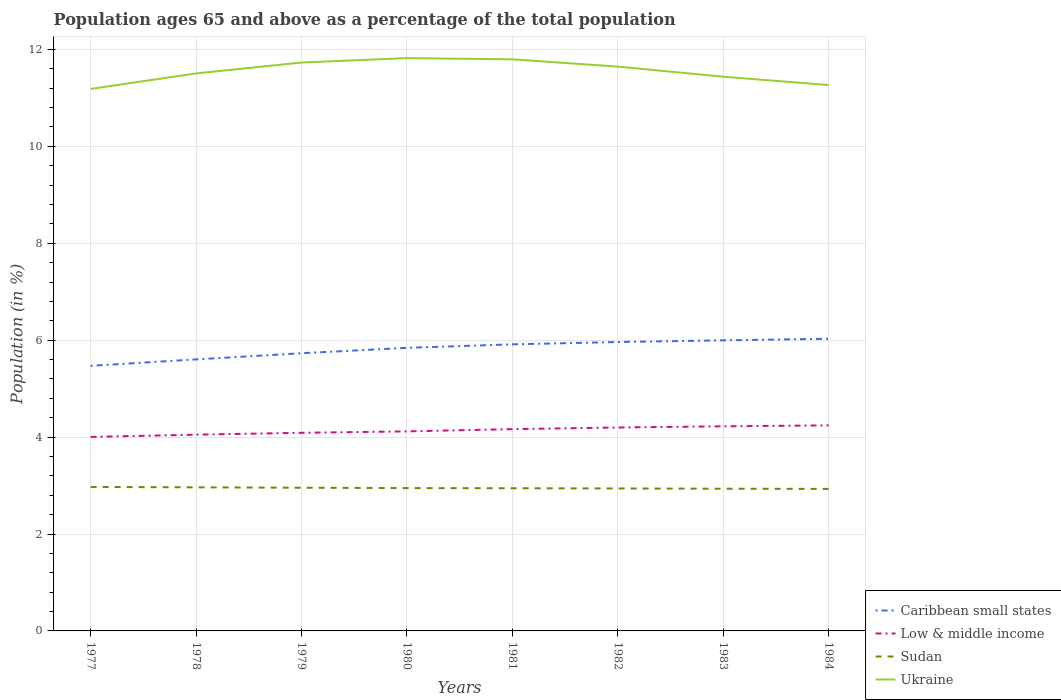How many different coloured lines are there?
Your answer should be very brief. 4. Does the line corresponding to Caribbean small states intersect with the line corresponding to Ukraine?
Give a very brief answer. No. Across all years, what is the maximum percentage of the population ages 65 and above in Ukraine?
Your answer should be compact. 11.18. What is the total percentage of the population ages 65 and above in Sudan in the graph?
Keep it short and to the point. 0.01. What is the difference between the highest and the second highest percentage of the population ages 65 and above in Ukraine?
Keep it short and to the point. 0.64. What is the difference between the highest and the lowest percentage of the population ages 65 and above in Caribbean small states?
Keep it short and to the point. 5. Is the percentage of the population ages 65 and above in Low & middle income strictly greater than the percentage of the population ages 65 and above in Sudan over the years?
Offer a terse response. No. What is the difference between two consecutive major ticks on the Y-axis?
Your response must be concise. 2. Does the graph contain any zero values?
Offer a very short reply. No. How are the legend labels stacked?
Ensure brevity in your answer.  Vertical. What is the title of the graph?
Provide a short and direct response. Population ages 65 and above as a percentage of the total population. What is the label or title of the Y-axis?
Your response must be concise. Population (in %). What is the Population (in %) of Caribbean small states in 1977?
Give a very brief answer. 5.47. What is the Population (in %) of Low & middle income in 1977?
Your response must be concise. 4. What is the Population (in %) in Sudan in 1977?
Your response must be concise. 2.97. What is the Population (in %) of Ukraine in 1977?
Give a very brief answer. 11.18. What is the Population (in %) in Caribbean small states in 1978?
Make the answer very short. 5.6. What is the Population (in %) in Low & middle income in 1978?
Offer a terse response. 4.05. What is the Population (in %) in Sudan in 1978?
Give a very brief answer. 2.96. What is the Population (in %) of Ukraine in 1978?
Your response must be concise. 11.5. What is the Population (in %) of Caribbean small states in 1979?
Your answer should be compact. 5.73. What is the Population (in %) of Low & middle income in 1979?
Provide a succinct answer. 4.09. What is the Population (in %) of Sudan in 1979?
Make the answer very short. 2.95. What is the Population (in %) of Ukraine in 1979?
Provide a short and direct response. 11.73. What is the Population (in %) of Caribbean small states in 1980?
Offer a terse response. 5.84. What is the Population (in %) in Low & middle income in 1980?
Your answer should be very brief. 4.12. What is the Population (in %) in Sudan in 1980?
Ensure brevity in your answer.  2.95. What is the Population (in %) in Ukraine in 1980?
Your answer should be compact. 11.82. What is the Population (in %) of Caribbean small states in 1981?
Give a very brief answer. 5.91. What is the Population (in %) in Low & middle income in 1981?
Ensure brevity in your answer.  4.16. What is the Population (in %) of Sudan in 1981?
Your answer should be very brief. 2.94. What is the Population (in %) in Ukraine in 1981?
Offer a terse response. 11.8. What is the Population (in %) of Caribbean small states in 1982?
Make the answer very short. 5.96. What is the Population (in %) of Low & middle income in 1982?
Offer a very short reply. 4.2. What is the Population (in %) of Sudan in 1982?
Provide a succinct answer. 2.94. What is the Population (in %) of Ukraine in 1982?
Your answer should be compact. 11.65. What is the Population (in %) of Caribbean small states in 1983?
Offer a terse response. 6. What is the Population (in %) in Low & middle income in 1983?
Provide a short and direct response. 4.22. What is the Population (in %) of Sudan in 1983?
Your answer should be very brief. 2.93. What is the Population (in %) of Ukraine in 1983?
Your answer should be very brief. 11.44. What is the Population (in %) in Caribbean small states in 1984?
Your answer should be very brief. 6.03. What is the Population (in %) in Low & middle income in 1984?
Offer a terse response. 4.24. What is the Population (in %) of Sudan in 1984?
Provide a succinct answer. 2.93. What is the Population (in %) of Ukraine in 1984?
Provide a succinct answer. 11.26. Across all years, what is the maximum Population (in %) of Caribbean small states?
Offer a very short reply. 6.03. Across all years, what is the maximum Population (in %) in Low & middle income?
Offer a terse response. 4.24. Across all years, what is the maximum Population (in %) in Sudan?
Keep it short and to the point. 2.97. Across all years, what is the maximum Population (in %) of Ukraine?
Provide a succinct answer. 11.82. Across all years, what is the minimum Population (in %) of Caribbean small states?
Offer a very short reply. 5.47. Across all years, what is the minimum Population (in %) in Low & middle income?
Make the answer very short. 4. Across all years, what is the minimum Population (in %) of Sudan?
Offer a terse response. 2.93. Across all years, what is the minimum Population (in %) of Ukraine?
Provide a short and direct response. 11.18. What is the total Population (in %) in Caribbean small states in the graph?
Provide a succinct answer. 46.55. What is the total Population (in %) in Low & middle income in the graph?
Offer a terse response. 33.09. What is the total Population (in %) of Sudan in the graph?
Offer a very short reply. 23.59. What is the total Population (in %) of Ukraine in the graph?
Make the answer very short. 92.38. What is the difference between the Population (in %) of Caribbean small states in 1977 and that in 1978?
Provide a succinct answer. -0.13. What is the difference between the Population (in %) in Low & middle income in 1977 and that in 1978?
Make the answer very short. -0.05. What is the difference between the Population (in %) of Sudan in 1977 and that in 1978?
Ensure brevity in your answer.  0.01. What is the difference between the Population (in %) of Ukraine in 1977 and that in 1978?
Keep it short and to the point. -0.32. What is the difference between the Population (in %) of Caribbean small states in 1977 and that in 1979?
Give a very brief answer. -0.26. What is the difference between the Population (in %) of Low & middle income in 1977 and that in 1979?
Give a very brief answer. -0.09. What is the difference between the Population (in %) of Sudan in 1977 and that in 1979?
Ensure brevity in your answer.  0.02. What is the difference between the Population (in %) in Ukraine in 1977 and that in 1979?
Keep it short and to the point. -0.54. What is the difference between the Population (in %) of Caribbean small states in 1977 and that in 1980?
Ensure brevity in your answer.  -0.37. What is the difference between the Population (in %) of Low & middle income in 1977 and that in 1980?
Your response must be concise. -0.11. What is the difference between the Population (in %) in Sudan in 1977 and that in 1980?
Offer a very short reply. 0.02. What is the difference between the Population (in %) in Ukraine in 1977 and that in 1980?
Ensure brevity in your answer.  -0.64. What is the difference between the Population (in %) in Caribbean small states in 1977 and that in 1981?
Your response must be concise. -0.44. What is the difference between the Population (in %) of Low & middle income in 1977 and that in 1981?
Offer a very short reply. -0.16. What is the difference between the Population (in %) of Sudan in 1977 and that in 1981?
Ensure brevity in your answer.  0.03. What is the difference between the Population (in %) of Ukraine in 1977 and that in 1981?
Provide a short and direct response. -0.61. What is the difference between the Population (in %) in Caribbean small states in 1977 and that in 1982?
Ensure brevity in your answer.  -0.49. What is the difference between the Population (in %) in Low & middle income in 1977 and that in 1982?
Provide a short and direct response. -0.19. What is the difference between the Population (in %) of Sudan in 1977 and that in 1982?
Your answer should be very brief. 0.03. What is the difference between the Population (in %) in Ukraine in 1977 and that in 1982?
Provide a short and direct response. -0.46. What is the difference between the Population (in %) in Caribbean small states in 1977 and that in 1983?
Make the answer very short. -0.53. What is the difference between the Population (in %) in Low & middle income in 1977 and that in 1983?
Your response must be concise. -0.22. What is the difference between the Population (in %) of Sudan in 1977 and that in 1983?
Keep it short and to the point. 0.04. What is the difference between the Population (in %) in Ukraine in 1977 and that in 1983?
Offer a very short reply. -0.25. What is the difference between the Population (in %) of Caribbean small states in 1977 and that in 1984?
Your answer should be very brief. -0.56. What is the difference between the Population (in %) in Low & middle income in 1977 and that in 1984?
Your answer should be very brief. -0.24. What is the difference between the Population (in %) of Sudan in 1977 and that in 1984?
Provide a short and direct response. 0.04. What is the difference between the Population (in %) in Ukraine in 1977 and that in 1984?
Provide a succinct answer. -0.08. What is the difference between the Population (in %) of Caribbean small states in 1978 and that in 1979?
Your answer should be compact. -0.13. What is the difference between the Population (in %) of Low & middle income in 1978 and that in 1979?
Your answer should be very brief. -0.04. What is the difference between the Population (in %) in Sudan in 1978 and that in 1979?
Keep it short and to the point. 0.01. What is the difference between the Population (in %) of Ukraine in 1978 and that in 1979?
Your answer should be very brief. -0.22. What is the difference between the Population (in %) in Caribbean small states in 1978 and that in 1980?
Make the answer very short. -0.24. What is the difference between the Population (in %) of Low & middle income in 1978 and that in 1980?
Your response must be concise. -0.07. What is the difference between the Population (in %) of Sudan in 1978 and that in 1980?
Keep it short and to the point. 0.02. What is the difference between the Population (in %) of Ukraine in 1978 and that in 1980?
Your answer should be very brief. -0.32. What is the difference between the Population (in %) of Caribbean small states in 1978 and that in 1981?
Offer a terse response. -0.31. What is the difference between the Population (in %) of Low & middle income in 1978 and that in 1981?
Provide a succinct answer. -0.11. What is the difference between the Population (in %) of Sudan in 1978 and that in 1981?
Provide a succinct answer. 0.02. What is the difference between the Population (in %) of Ukraine in 1978 and that in 1981?
Make the answer very short. -0.29. What is the difference between the Population (in %) of Caribbean small states in 1978 and that in 1982?
Your answer should be compact. -0.36. What is the difference between the Population (in %) in Low & middle income in 1978 and that in 1982?
Your answer should be very brief. -0.15. What is the difference between the Population (in %) in Sudan in 1978 and that in 1982?
Keep it short and to the point. 0.02. What is the difference between the Population (in %) of Ukraine in 1978 and that in 1982?
Offer a terse response. -0.14. What is the difference between the Population (in %) of Caribbean small states in 1978 and that in 1983?
Your response must be concise. -0.39. What is the difference between the Population (in %) in Low & middle income in 1978 and that in 1983?
Offer a terse response. -0.17. What is the difference between the Population (in %) of Sudan in 1978 and that in 1983?
Your response must be concise. 0.03. What is the difference between the Population (in %) of Ukraine in 1978 and that in 1983?
Your answer should be very brief. 0.07. What is the difference between the Population (in %) in Caribbean small states in 1978 and that in 1984?
Make the answer very short. -0.43. What is the difference between the Population (in %) in Low & middle income in 1978 and that in 1984?
Your answer should be very brief. -0.19. What is the difference between the Population (in %) of Sudan in 1978 and that in 1984?
Make the answer very short. 0.03. What is the difference between the Population (in %) of Ukraine in 1978 and that in 1984?
Make the answer very short. 0.24. What is the difference between the Population (in %) in Caribbean small states in 1979 and that in 1980?
Offer a terse response. -0.11. What is the difference between the Population (in %) in Low & middle income in 1979 and that in 1980?
Give a very brief answer. -0.03. What is the difference between the Population (in %) in Sudan in 1979 and that in 1980?
Offer a very short reply. 0.01. What is the difference between the Population (in %) of Ukraine in 1979 and that in 1980?
Keep it short and to the point. -0.09. What is the difference between the Population (in %) of Caribbean small states in 1979 and that in 1981?
Offer a terse response. -0.18. What is the difference between the Population (in %) in Low & middle income in 1979 and that in 1981?
Give a very brief answer. -0.08. What is the difference between the Population (in %) in Sudan in 1979 and that in 1981?
Your answer should be very brief. 0.01. What is the difference between the Population (in %) in Ukraine in 1979 and that in 1981?
Offer a very short reply. -0.07. What is the difference between the Population (in %) of Caribbean small states in 1979 and that in 1982?
Ensure brevity in your answer.  -0.23. What is the difference between the Population (in %) in Low & middle income in 1979 and that in 1982?
Your answer should be compact. -0.11. What is the difference between the Population (in %) in Sudan in 1979 and that in 1982?
Provide a succinct answer. 0.02. What is the difference between the Population (in %) of Ukraine in 1979 and that in 1982?
Offer a terse response. 0.08. What is the difference between the Population (in %) in Caribbean small states in 1979 and that in 1983?
Make the answer very short. -0.27. What is the difference between the Population (in %) in Low & middle income in 1979 and that in 1983?
Your answer should be very brief. -0.13. What is the difference between the Population (in %) of Sudan in 1979 and that in 1983?
Ensure brevity in your answer.  0.02. What is the difference between the Population (in %) in Ukraine in 1979 and that in 1983?
Your response must be concise. 0.29. What is the difference between the Population (in %) of Caribbean small states in 1979 and that in 1984?
Your answer should be compact. -0.3. What is the difference between the Population (in %) of Low & middle income in 1979 and that in 1984?
Provide a short and direct response. -0.15. What is the difference between the Population (in %) in Sudan in 1979 and that in 1984?
Ensure brevity in your answer.  0.02. What is the difference between the Population (in %) in Ukraine in 1979 and that in 1984?
Provide a short and direct response. 0.47. What is the difference between the Population (in %) of Caribbean small states in 1980 and that in 1981?
Give a very brief answer. -0.07. What is the difference between the Population (in %) of Low & middle income in 1980 and that in 1981?
Offer a very short reply. -0.05. What is the difference between the Population (in %) of Sudan in 1980 and that in 1981?
Offer a terse response. 0. What is the difference between the Population (in %) in Ukraine in 1980 and that in 1981?
Provide a short and direct response. 0.03. What is the difference between the Population (in %) of Caribbean small states in 1980 and that in 1982?
Ensure brevity in your answer.  -0.12. What is the difference between the Population (in %) in Low & middle income in 1980 and that in 1982?
Ensure brevity in your answer.  -0.08. What is the difference between the Population (in %) of Sudan in 1980 and that in 1982?
Provide a short and direct response. 0.01. What is the difference between the Population (in %) of Ukraine in 1980 and that in 1982?
Make the answer very short. 0.18. What is the difference between the Population (in %) of Caribbean small states in 1980 and that in 1983?
Your answer should be compact. -0.15. What is the difference between the Population (in %) of Low & middle income in 1980 and that in 1983?
Ensure brevity in your answer.  -0.1. What is the difference between the Population (in %) of Sudan in 1980 and that in 1983?
Offer a very short reply. 0.01. What is the difference between the Population (in %) in Ukraine in 1980 and that in 1983?
Offer a very short reply. 0.38. What is the difference between the Population (in %) of Caribbean small states in 1980 and that in 1984?
Keep it short and to the point. -0.19. What is the difference between the Population (in %) in Low & middle income in 1980 and that in 1984?
Keep it short and to the point. -0.12. What is the difference between the Population (in %) of Sudan in 1980 and that in 1984?
Your answer should be compact. 0.02. What is the difference between the Population (in %) in Ukraine in 1980 and that in 1984?
Your answer should be very brief. 0.56. What is the difference between the Population (in %) of Caribbean small states in 1981 and that in 1982?
Keep it short and to the point. -0.05. What is the difference between the Population (in %) in Low & middle income in 1981 and that in 1982?
Your answer should be very brief. -0.03. What is the difference between the Population (in %) of Sudan in 1981 and that in 1982?
Make the answer very short. 0. What is the difference between the Population (in %) in Ukraine in 1981 and that in 1982?
Provide a short and direct response. 0.15. What is the difference between the Population (in %) of Caribbean small states in 1981 and that in 1983?
Ensure brevity in your answer.  -0.08. What is the difference between the Population (in %) in Low & middle income in 1981 and that in 1983?
Offer a terse response. -0.06. What is the difference between the Population (in %) of Sudan in 1981 and that in 1983?
Ensure brevity in your answer.  0.01. What is the difference between the Population (in %) in Ukraine in 1981 and that in 1983?
Make the answer very short. 0.36. What is the difference between the Population (in %) of Caribbean small states in 1981 and that in 1984?
Make the answer very short. -0.12. What is the difference between the Population (in %) in Low & middle income in 1981 and that in 1984?
Your response must be concise. -0.08. What is the difference between the Population (in %) in Sudan in 1981 and that in 1984?
Provide a succinct answer. 0.01. What is the difference between the Population (in %) in Ukraine in 1981 and that in 1984?
Keep it short and to the point. 0.53. What is the difference between the Population (in %) of Caribbean small states in 1982 and that in 1983?
Your answer should be compact. -0.03. What is the difference between the Population (in %) of Low & middle income in 1982 and that in 1983?
Offer a very short reply. -0.02. What is the difference between the Population (in %) of Sudan in 1982 and that in 1983?
Provide a succinct answer. 0.01. What is the difference between the Population (in %) in Ukraine in 1982 and that in 1983?
Make the answer very short. 0.21. What is the difference between the Population (in %) of Caribbean small states in 1982 and that in 1984?
Give a very brief answer. -0.07. What is the difference between the Population (in %) in Low & middle income in 1982 and that in 1984?
Keep it short and to the point. -0.04. What is the difference between the Population (in %) of Sudan in 1982 and that in 1984?
Make the answer very short. 0.01. What is the difference between the Population (in %) in Ukraine in 1982 and that in 1984?
Give a very brief answer. 0.38. What is the difference between the Population (in %) of Caribbean small states in 1983 and that in 1984?
Offer a terse response. -0.03. What is the difference between the Population (in %) of Low & middle income in 1983 and that in 1984?
Provide a short and direct response. -0.02. What is the difference between the Population (in %) of Sudan in 1983 and that in 1984?
Your response must be concise. 0. What is the difference between the Population (in %) in Ukraine in 1983 and that in 1984?
Make the answer very short. 0.17. What is the difference between the Population (in %) of Caribbean small states in 1977 and the Population (in %) of Low & middle income in 1978?
Give a very brief answer. 1.42. What is the difference between the Population (in %) of Caribbean small states in 1977 and the Population (in %) of Sudan in 1978?
Your answer should be compact. 2.51. What is the difference between the Population (in %) of Caribbean small states in 1977 and the Population (in %) of Ukraine in 1978?
Give a very brief answer. -6.03. What is the difference between the Population (in %) in Low & middle income in 1977 and the Population (in %) in Ukraine in 1978?
Make the answer very short. -7.5. What is the difference between the Population (in %) in Sudan in 1977 and the Population (in %) in Ukraine in 1978?
Provide a short and direct response. -8.53. What is the difference between the Population (in %) in Caribbean small states in 1977 and the Population (in %) in Low & middle income in 1979?
Keep it short and to the point. 1.38. What is the difference between the Population (in %) in Caribbean small states in 1977 and the Population (in %) in Sudan in 1979?
Make the answer very short. 2.52. What is the difference between the Population (in %) of Caribbean small states in 1977 and the Population (in %) of Ukraine in 1979?
Your response must be concise. -6.26. What is the difference between the Population (in %) in Low & middle income in 1977 and the Population (in %) in Sudan in 1979?
Your answer should be compact. 1.05. What is the difference between the Population (in %) in Low & middle income in 1977 and the Population (in %) in Ukraine in 1979?
Offer a very short reply. -7.73. What is the difference between the Population (in %) of Sudan in 1977 and the Population (in %) of Ukraine in 1979?
Offer a terse response. -8.76. What is the difference between the Population (in %) in Caribbean small states in 1977 and the Population (in %) in Low & middle income in 1980?
Your answer should be very brief. 1.35. What is the difference between the Population (in %) of Caribbean small states in 1977 and the Population (in %) of Sudan in 1980?
Your response must be concise. 2.52. What is the difference between the Population (in %) in Caribbean small states in 1977 and the Population (in %) in Ukraine in 1980?
Provide a succinct answer. -6.35. What is the difference between the Population (in %) in Low & middle income in 1977 and the Population (in %) in Sudan in 1980?
Make the answer very short. 1.06. What is the difference between the Population (in %) of Low & middle income in 1977 and the Population (in %) of Ukraine in 1980?
Your answer should be very brief. -7.82. What is the difference between the Population (in %) in Sudan in 1977 and the Population (in %) in Ukraine in 1980?
Your answer should be very brief. -8.85. What is the difference between the Population (in %) in Caribbean small states in 1977 and the Population (in %) in Low & middle income in 1981?
Offer a terse response. 1.31. What is the difference between the Population (in %) of Caribbean small states in 1977 and the Population (in %) of Sudan in 1981?
Keep it short and to the point. 2.53. What is the difference between the Population (in %) of Caribbean small states in 1977 and the Population (in %) of Ukraine in 1981?
Make the answer very short. -6.32. What is the difference between the Population (in %) of Low & middle income in 1977 and the Population (in %) of Sudan in 1981?
Provide a succinct answer. 1.06. What is the difference between the Population (in %) of Low & middle income in 1977 and the Population (in %) of Ukraine in 1981?
Provide a succinct answer. -7.79. What is the difference between the Population (in %) in Sudan in 1977 and the Population (in %) in Ukraine in 1981?
Your answer should be very brief. -8.82. What is the difference between the Population (in %) of Caribbean small states in 1977 and the Population (in %) of Low & middle income in 1982?
Offer a very short reply. 1.27. What is the difference between the Population (in %) of Caribbean small states in 1977 and the Population (in %) of Sudan in 1982?
Provide a succinct answer. 2.53. What is the difference between the Population (in %) in Caribbean small states in 1977 and the Population (in %) in Ukraine in 1982?
Your response must be concise. -6.17. What is the difference between the Population (in %) in Low & middle income in 1977 and the Population (in %) in Sudan in 1982?
Offer a very short reply. 1.06. What is the difference between the Population (in %) of Low & middle income in 1977 and the Population (in %) of Ukraine in 1982?
Your answer should be very brief. -7.64. What is the difference between the Population (in %) in Sudan in 1977 and the Population (in %) in Ukraine in 1982?
Provide a short and direct response. -8.67. What is the difference between the Population (in %) of Caribbean small states in 1977 and the Population (in %) of Low & middle income in 1983?
Offer a terse response. 1.25. What is the difference between the Population (in %) in Caribbean small states in 1977 and the Population (in %) in Sudan in 1983?
Make the answer very short. 2.54. What is the difference between the Population (in %) in Caribbean small states in 1977 and the Population (in %) in Ukraine in 1983?
Provide a short and direct response. -5.97. What is the difference between the Population (in %) in Low & middle income in 1977 and the Population (in %) in Sudan in 1983?
Give a very brief answer. 1.07. What is the difference between the Population (in %) of Low & middle income in 1977 and the Population (in %) of Ukraine in 1983?
Ensure brevity in your answer.  -7.43. What is the difference between the Population (in %) in Sudan in 1977 and the Population (in %) in Ukraine in 1983?
Give a very brief answer. -8.47. What is the difference between the Population (in %) in Caribbean small states in 1977 and the Population (in %) in Low & middle income in 1984?
Keep it short and to the point. 1.23. What is the difference between the Population (in %) in Caribbean small states in 1977 and the Population (in %) in Sudan in 1984?
Offer a very short reply. 2.54. What is the difference between the Population (in %) of Caribbean small states in 1977 and the Population (in %) of Ukraine in 1984?
Provide a short and direct response. -5.79. What is the difference between the Population (in %) in Low & middle income in 1977 and the Population (in %) in Sudan in 1984?
Provide a succinct answer. 1.07. What is the difference between the Population (in %) of Low & middle income in 1977 and the Population (in %) of Ukraine in 1984?
Your response must be concise. -7.26. What is the difference between the Population (in %) of Sudan in 1977 and the Population (in %) of Ukraine in 1984?
Offer a very short reply. -8.29. What is the difference between the Population (in %) of Caribbean small states in 1978 and the Population (in %) of Low & middle income in 1979?
Provide a short and direct response. 1.51. What is the difference between the Population (in %) in Caribbean small states in 1978 and the Population (in %) in Sudan in 1979?
Provide a succinct answer. 2.65. What is the difference between the Population (in %) of Caribbean small states in 1978 and the Population (in %) of Ukraine in 1979?
Ensure brevity in your answer.  -6.13. What is the difference between the Population (in %) in Low & middle income in 1978 and the Population (in %) in Sudan in 1979?
Ensure brevity in your answer.  1.09. What is the difference between the Population (in %) in Low & middle income in 1978 and the Population (in %) in Ukraine in 1979?
Give a very brief answer. -7.68. What is the difference between the Population (in %) in Sudan in 1978 and the Population (in %) in Ukraine in 1979?
Your answer should be compact. -8.77. What is the difference between the Population (in %) of Caribbean small states in 1978 and the Population (in %) of Low & middle income in 1980?
Your answer should be compact. 1.49. What is the difference between the Population (in %) of Caribbean small states in 1978 and the Population (in %) of Sudan in 1980?
Offer a very short reply. 2.66. What is the difference between the Population (in %) of Caribbean small states in 1978 and the Population (in %) of Ukraine in 1980?
Your response must be concise. -6.22. What is the difference between the Population (in %) in Low & middle income in 1978 and the Population (in %) in Sudan in 1980?
Ensure brevity in your answer.  1.1. What is the difference between the Population (in %) of Low & middle income in 1978 and the Population (in %) of Ukraine in 1980?
Provide a short and direct response. -7.77. What is the difference between the Population (in %) of Sudan in 1978 and the Population (in %) of Ukraine in 1980?
Offer a terse response. -8.86. What is the difference between the Population (in %) of Caribbean small states in 1978 and the Population (in %) of Low & middle income in 1981?
Provide a short and direct response. 1.44. What is the difference between the Population (in %) in Caribbean small states in 1978 and the Population (in %) in Sudan in 1981?
Your answer should be compact. 2.66. What is the difference between the Population (in %) in Caribbean small states in 1978 and the Population (in %) in Ukraine in 1981?
Ensure brevity in your answer.  -6.19. What is the difference between the Population (in %) of Low & middle income in 1978 and the Population (in %) of Sudan in 1981?
Offer a very short reply. 1.11. What is the difference between the Population (in %) of Low & middle income in 1978 and the Population (in %) of Ukraine in 1981?
Make the answer very short. -7.75. What is the difference between the Population (in %) of Sudan in 1978 and the Population (in %) of Ukraine in 1981?
Your response must be concise. -8.83. What is the difference between the Population (in %) in Caribbean small states in 1978 and the Population (in %) in Low & middle income in 1982?
Make the answer very short. 1.41. What is the difference between the Population (in %) in Caribbean small states in 1978 and the Population (in %) in Sudan in 1982?
Your response must be concise. 2.66. What is the difference between the Population (in %) of Caribbean small states in 1978 and the Population (in %) of Ukraine in 1982?
Provide a short and direct response. -6.04. What is the difference between the Population (in %) in Low & middle income in 1978 and the Population (in %) in Sudan in 1982?
Keep it short and to the point. 1.11. What is the difference between the Population (in %) in Low & middle income in 1978 and the Population (in %) in Ukraine in 1982?
Offer a very short reply. -7.6. What is the difference between the Population (in %) in Sudan in 1978 and the Population (in %) in Ukraine in 1982?
Your answer should be compact. -8.68. What is the difference between the Population (in %) in Caribbean small states in 1978 and the Population (in %) in Low & middle income in 1983?
Provide a short and direct response. 1.38. What is the difference between the Population (in %) of Caribbean small states in 1978 and the Population (in %) of Sudan in 1983?
Offer a terse response. 2.67. What is the difference between the Population (in %) of Caribbean small states in 1978 and the Population (in %) of Ukraine in 1983?
Provide a short and direct response. -5.83. What is the difference between the Population (in %) of Low & middle income in 1978 and the Population (in %) of Sudan in 1983?
Your response must be concise. 1.12. What is the difference between the Population (in %) of Low & middle income in 1978 and the Population (in %) of Ukraine in 1983?
Make the answer very short. -7.39. What is the difference between the Population (in %) of Sudan in 1978 and the Population (in %) of Ukraine in 1983?
Provide a short and direct response. -8.47. What is the difference between the Population (in %) in Caribbean small states in 1978 and the Population (in %) in Low & middle income in 1984?
Your answer should be compact. 1.36. What is the difference between the Population (in %) of Caribbean small states in 1978 and the Population (in %) of Sudan in 1984?
Ensure brevity in your answer.  2.67. What is the difference between the Population (in %) of Caribbean small states in 1978 and the Population (in %) of Ukraine in 1984?
Offer a very short reply. -5.66. What is the difference between the Population (in %) in Low & middle income in 1978 and the Population (in %) in Sudan in 1984?
Your answer should be compact. 1.12. What is the difference between the Population (in %) in Low & middle income in 1978 and the Population (in %) in Ukraine in 1984?
Provide a short and direct response. -7.21. What is the difference between the Population (in %) of Sudan in 1978 and the Population (in %) of Ukraine in 1984?
Make the answer very short. -8.3. What is the difference between the Population (in %) in Caribbean small states in 1979 and the Population (in %) in Low & middle income in 1980?
Keep it short and to the point. 1.61. What is the difference between the Population (in %) in Caribbean small states in 1979 and the Population (in %) in Sudan in 1980?
Give a very brief answer. 2.78. What is the difference between the Population (in %) of Caribbean small states in 1979 and the Population (in %) of Ukraine in 1980?
Offer a very short reply. -6.09. What is the difference between the Population (in %) in Low & middle income in 1979 and the Population (in %) in Sudan in 1980?
Your answer should be very brief. 1.14. What is the difference between the Population (in %) of Low & middle income in 1979 and the Population (in %) of Ukraine in 1980?
Offer a very short reply. -7.73. What is the difference between the Population (in %) of Sudan in 1979 and the Population (in %) of Ukraine in 1980?
Ensure brevity in your answer.  -8.87. What is the difference between the Population (in %) of Caribbean small states in 1979 and the Population (in %) of Low & middle income in 1981?
Provide a succinct answer. 1.57. What is the difference between the Population (in %) in Caribbean small states in 1979 and the Population (in %) in Sudan in 1981?
Provide a succinct answer. 2.79. What is the difference between the Population (in %) of Caribbean small states in 1979 and the Population (in %) of Ukraine in 1981?
Your answer should be compact. -6.06. What is the difference between the Population (in %) of Low & middle income in 1979 and the Population (in %) of Sudan in 1981?
Your response must be concise. 1.14. What is the difference between the Population (in %) of Low & middle income in 1979 and the Population (in %) of Ukraine in 1981?
Your answer should be compact. -7.71. What is the difference between the Population (in %) in Sudan in 1979 and the Population (in %) in Ukraine in 1981?
Provide a short and direct response. -8.84. What is the difference between the Population (in %) of Caribbean small states in 1979 and the Population (in %) of Low & middle income in 1982?
Offer a terse response. 1.53. What is the difference between the Population (in %) of Caribbean small states in 1979 and the Population (in %) of Sudan in 1982?
Your response must be concise. 2.79. What is the difference between the Population (in %) in Caribbean small states in 1979 and the Population (in %) in Ukraine in 1982?
Give a very brief answer. -5.92. What is the difference between the Population (in %) of Low & middle income in 1979 and the Population (in %) of Sudan in 1982?
Ensure brevity in your answer.  1.15. What is the difference between the Population (in %) of Low & middle income in 1979 and the Population (in %) of Ukraine in 1982?
Give a very brief answer. -7.56. What is the difference between the Population (in %) of Sudan in 1979 and the Population (in %) of Ukraine in 1982?
Your answer should be very brief. -8.69. What is the difference between the Population (in %) in Caribbean small states in 1979 and the Population (in %) in Low & middle income in 1983?
Offer a terse response. 1.51. What is the difference between the Population (in %) of Caribbean small states in 1979 and the Population (in %) of Sudan in 1983?
Keep it short and to the point. 2.8. What is the difference between the Population (in %) of Caribbean small states in 1979 and the Population (in %) of Ukraine in 1983?
Ensure brevity in your answer.  -5.71. What is the difference between the Population (in %) in Low & middle income in 1979 and the Population (in %) in Sudan in 1983?
Offer a very short reply. 1.15. What is the difference between the Population (in %) in Low & middle income in 1979 and the Population (in %) in Ukraine in 1983?
Ensure brevity in your answer.  -7.35. What is the difference between the Population (in %) in Sudan in 1979 and the Population (in %) in Ukraine in 1983?
Provide a succinct answer. -8.48. What is the difference between the Population (in %) of Caribbean small states in 1979 and the Population (in %) of Low & middle income in 1984?
Your answer should be compact. 1.49. What is the difference between the Population (in %) of Caribbean small states in 1979 and the Population (in %) of Sudan in 1984?
Ensure brevity in your answer.  2.8. What is the difference between the Population (in %) in Caribbean small states in 1979 and the Population (in %) in Ukraine in 1984?
Your response must be concise. -5.53. What is the difference between the Population (in %) in Low & middle income in 1979 and the Population (in %) in Sudan in 1984?
Give a very brief answer. 1.16. What is the difference between the Population (in %) in Low & middle income in 1979 and the Population (in %) in Ukraine in 1984?
Offer a very short reply. -7.18. What is the difference between the Population (in %) of Sudan in 1979 and the Population (in %) of Ukraine in 1984?
Give a very brief answer. -8.31. What is the difference between the Population (in %) in Caribbean small states in 1980 and the Population (in %) in Low & middle income in 1981?
Your answer should be very brief. 1.68. What is the difference between the Population (in %) of Caribbean small states in 1980 and the Population (in %) of Sudan in 1981?
Ensure brevity in your answer.  2.9. What is the difference between the Population (in %) in Caribbean small states in 1980 and the Population (in %) in Ukraine in 1981?
Your answer should be very brief. -5.95. What is the difference between the Population (in %) of Low & middle income in 1980 and the Population (in %) of Sudan in 1981?
Give a very brief answer. 1.17. What is the difference between the Population (in %) in Low & middle income in 1980 and the Population (in %) in Ukraine in 1981?
Ensure brevity in your answer.  -7.68. What is the difference between the Population (in %) of Sudan in 1980 and the Population (in %) of Ukraine in 1981?
Give a very brief answer. -8.85. What is the difference between the Population (in %) of Caribbean small states in 1980 and the Population (in %) of Low & middle income in 1982?
Provide a short and direct response. 1.64. What is the difference between the Population (in %) of Caribbean small states in 1980 and the Population (in %) of Sudan in 1982?
Your answer should be compact. 2.9. What is the difference between the Population (in %) in Caribbean small states in 1980 and the Population (in %) in Ukraine in 1982?
Offer a very short reply. -5.8. What is the difference between the Population (in %) in Low & middle income in 1980 and the Population (in %) in Sudan in 1982?
Offer a very short reply. 1.18. What is the difference between the Population (in %) in Low & middle income in 1980 and the Population (in %) in Ukraine in 1982?
Your answer should be very brief. -7.53. What is the difference between the Population (in %) in Sudan in 1980 and the Population (in %) in Ukraine in 1982?
Provide a short and direct response. -8.7. What is the difference between the Population (in %) of Caribbean small states in 1980 and the Population (in %) of Low & middle income in 1983?
Give a very brief answer. 1.62. What is the difference between the Population (in %) of Caribbean small states in 1980 and the Population (in %) of Sudan in 1983?
Offer a very short reply. 2.91. What is the difference between the Population (in %) of Caribbean small states in 1980 and the Population (in %) of Ukraine in 1983?
Your response must be concise. -5.6. What is the difference between the Population (in %) in Low & middle income in 1980 and the Population (in %) in Sudan in 1983?
Your response must be concise. 1.18. What is the difference between the Population (in %) in Low & middle income in 1980 and the Population (in %) in Ukraine in 1983?
Your answer should be very brief. -7.32. What is the difference between the Population (in %) of Sudan in 1980 and the Population (in %) of Ukraine in 1983?
Give a very brief answer. -8.49. What is the difference between the Population (in %) of Caribbean small states in 1980 and the Population (in %) of Low & middle income in 1984?
Provide a short and direct response. 1.6. What is the difference between the Population (in %) of Caribbean small states in 1980 and the Population (in %) of Sudan in 1984?
Your response must be concise. 2.91. What is the difference between the Population (in %) of Caribbean small states in 1980 and the Population (in %) of Ukraine in 1984?
Keep it short and to the point. -5.42. What is the difference between the Population (in %) of Low & middle income in 1980 and the Population (in %) of Sudan in 1984?
Offer a very short reply. 1.19. What is the difference between the Population (in %) in Low & middle income in 1980 and the Population (in %) in Ukraine in 1984?
Your response must be concise. -7.15. What is the difference between the Population (in %) of Sudan in 1980 and the Population (in %) of Ukraine in 1984?
Your response must be concise. -8.32. What is the difference between the Population (in %) in Caribbean small states in 1981 and the Population (in %) in Low & middle income in 1982?
Provide a succinct answer. 1.72. What is the difference between the Population (in %) in Caribbean small states in 1981 and the Population (in %) in Sudan in 1982?
Your answer should be compact. 2.97. What is the difference between the Population (in %) of Caribbean small states in 1981 and the Population (in %) of Ukraine in 1982?
Keep it short and to the point. -5.73. What is the difference between the Population (in %) of Low & middle income in 1981 and the Population (in %) of Sudan in 1982?
Your answer should be compact. 1.22. What is the difference between the Population (in %) in Low & middle income in 1981 and the Population (in %) in Ukraine in 1982?
Give a very brief answer. -7.48. What is the difference between the Population (in %) of Sudan in 1981 and the Population (in %) of Ukraine in 1982?
Make the answer very short. -8.7. What is the difference between the Population (in %) in Caribbean small states in 1981 and the Population (in %) in Low & middle income in 1983?
Ensure brevity in your answer.  1.69. What is the difference between the Population (in %) in Caribbean small states in 1981 and the Population (in %) in Sudan in 1983?
Offer a very short reply. 2.98. What is the difference between the Population (in %) of Caribbean small states in 1981 and the Population (in %) of Ukraine in 1983?
Give a very brief answer. -5.52. What is the difference between the Population (in %) in Low & middle income in 1981 and the Population (in %) in Sudan in 1983?
Keep it short and to the point. 1.23. What is the difference between the Population (in %) of Low & middle income in 1981 and the Population (in %) of Ukraine in 1983?
Your response must be concise. -7.27. What is the difference between the Population (in %) in Sudan in 1981 and the Population (in %) in Ukraine in 1983?
Make the answer very short. -8.49. What is the difference between the Population (in %) in Caribbean small states in 1981 and the Population (in %) in Low & middle income in 1984?
Make the answer very short. 1.67. What is the difference between the Population (in %) of Caribbean small states in 1981 and the Population (in %) of Sudan in 1984?
Offer a terse response. 2.98. What is the difference between the Population (in %) in Caribbean small states in 1981 and the Population (in %) in Ukraine in 1984?
Make the answer very short. -5.35. What is the difference between the Population (in %) in Low & middle income in 1981 and the Population (in %) in Sudan in 1984?
Offer a very short reply. 1.23. What is the difference between the Population (in %) in Low & middle income in 1981 and the Population (in %) in Ukraine in 1984?
Ensure brevity in your answer.  -7.1. What is the difference between the Population (in %) in Sudan in 1981 and the Population (in %) in Ukraine in 1984?
Offer a terse response. -8.32. What is the difference between the Population (in %) in Caribbean small states in 1982 and the Population (in %) in Low & middle income in 1983?
Keep it short and to the point. 1.74. What is the difference between the Population (in %) of Caribbean small states in 1982 and the Population (in %) of Sudan in 1983?
Your answer should be compact. 3.03. What is the difference between the Population (in %) of Caribbean small states in 1982 and the Population (in %) of Ukraine in 1983?
Make the answer very short. -5.48. What is the difference between the Population (in %) in Low & middle income in 1982 and the Population (in %) in Sudan in 1983?
Provide a short and direct response. 1.26. What is the difference between the Population (in %) of Low & middle income in 1982 and the Population (in %) of Ukraine in 1983?
Your answer should be very brief. -7.24. What is the difference between the Population (in %) of Sudan in 1982 and the Population (in %) of Ukraine in 1983?
Make the answer very short. -8.5. What is the difference between the Population (in %) of Caribbean small states in 1982 and the Population (in %) of Low & middle income in 1984?
Offer a very short reply. 1.72. What is the difference between the Population (in %) in Caribbean small states in 1982 and the Population (in %) in Sudan in 1984?
Make the answer very short. 3.03. What is the difference between the Population (in %) in Caribbean small states in 1982 and the Population (in %) in Ukraine in 1984?
Your answer should be compact. -5.3. What is the difference between the Population (in %) in Low & middle income in 1982 and the Population (in %) in Sudan in 1984?
Offer a terse response. 1.27. What is the difference between the Population (in %) of Low & middle income in 1982 and the Population (in %) of Ukraine in 1984?
Offer a terse response. -7.07. What is the difference between the Population (in %) of Sudan in 1982 and the Population (in %) of Ukraine in 1984?
Give a very brief answer. -8.32. What is the difference between the Population (in %) in Caribbean small states in 1983 and the Population (in %) in Low & middle income in 1984?
Provide a succinct answer. 1.75. What is the difference between the Population (in %) of Caribbean small states in 1983 and the Population (in %) of Sudan in 1984?
Ensure brevity in your answer.  3.07. What is the difference between the Population (in %) of Caribbean small states in 1983 and the Population (in %) of Ukraine in 1984?
Ensure brevity in your answer.  -5.27. What is the difference between the Population (in %) of Low & middle income in 1983 and the Population (in %) of Sudan in 1984?
Your answer should be very brief. 1.29. What is the difference between the Population (in %) of Low & middle income in 1983 and the Population (in %) of Ukraine in 1984?
Your response must be concise. -7.04. What is the difference between the Population (in %) of Sudan in 1983 and the Population (in %) of Ukraine in 1984?
Give a very brief answer. -8.33. What is the average Population (in %) in Caribbean small states per year?
Make the answer very short. 5.82. What is the average Population (in %) of Low & middle income per year?
Offer a terse response. 4.14. What is the average Population (in %) in Sudan per year?
Offer a terse response. 2.95. What is the average Population (in %) of Ukraine per year?
Your response must be concise. 11.55. In the year 1977, what is the difference between the Population (in %) in Caribbean small states and Population (in %) in Low & middle income?
Provide a short and direct response. 1.47. In the year 1977, what is the difference between the Population (in %) of Caribbean small states and Population (in %) of Sudan?
Provide a succinct answer. 2.5. In the year 1977, what is the difference between the Population (in %) of Caribbean small states and Population (in %) of Ukraine?
Ensure brevity in your answer.  -5.71. In the year 1977, what is the difference between the Population (in %) in Low & middle income and Population (in %) in Sudan?
Your response must be concise. 1.03. In the year 1977, what is the difference between the Population (in %) of Low & middle income and Population (in %) of Ukraine?
Your response must be concise. -7.18. In the year 1977, what is the difference between the Population (in %) in Sudan and Population (in %) in Ukraine?
Ensure brevity in your answer.  -8.21. In the year 1978, what is the difference between the Population (in %) in Caribbean small states and Population (in %) in Low & middle income?
Make the answer very short. 1.55. In the year 1978, what is the difference between the Population (in %) in Caribbean small states and Population (in %) in Sudan?
Keep it short and to the point. 2.64. In the year 1978, what is the difference between the Population (in %) of Caribbean small states and Population (in %) of Ukraine?
Offer a very short reply. -5.9. In the year 1978, what is the difference between the Population (in %) of Low & middle income and Population (in %) of Sudan?
Your answer should be very brief. 1.09. In the year 1978, what is the difference between the Population (in %) of Low & middle income and Population (in %) of Ukraine?
Offer a very short reply. -7.45. In the year 1978, what is the difference between the Population (in %) of Sudan and Population (in %) of Ukraine?
Make the answer very short. -8.54. In the year 1979, what is the difference between the Population (in %) of Caribbean small states and Population (in %) of Low & middle income?
Keep it short and to the point. 1.64. In the year 1979, what is the difference between the Population (in %) of Caribbean small states and Population (in %) of Sudan?
Your answer should be very brief. 2.78. In the year 1979, what is the difference between the Population (in %) of Caribbean small states and Population (in %) of Ukraine?
Give a very brief answer. -6. In the year 1979, what is the difference between the Population (in %) of Low & middle income and Population (in %) of Sudan?
Offer a very short reply. 1.13. In the year 1979, what is the difference between the Population (in %) in Low & middle income and Population (in %) in Ukraine?
Your response must be concise. -7.64. In the year 1979, what is the difference between the Population (in %) in Sudan and Population (in %) in Ukraine?
Offer a very short reply. -8.77. In the year 1980, what is the difference between the Population (in %) of Caribbean small states and Population (in %) of Low & middle income?
Your answer should be compact. 1.72. In the year 1980, what is the difference between the Population (in %) of Caribbean small states and Population (in %) of Sudan?
Offer a very short reply. 2.89. In the year 1980, what is the difference between the Population (in %) of Caribbean small states and Population (in %) of Ukraine?
Offer a very short reply. -5.98. In the year 1980, what is the difference between the Population (in %) of Low & middle income and Population (in %) of Sudan?
Ensure brevity in your answer.  1.17. In the year 1980, what is the difference between the Population (in %) in Low & middle income and Population (in %) in Ukraine?
Keep it short and to the point. -7.7. In the year 1980, what is the difference between the Population (in %) in Sudan and Population (in %) in Ukraine?
Keep it short and to the point. -8.87. In the year 1981, what is the difference between the Population (in %) of Caribbean small states and Population (in %) of Low & middle income?
Provide a succinct answer. 1.75. In the year 1981, what is the difference between the Population (in %) of Caribbean small states and Population (in %) of Sudan?
Give a very brief answer. 2.97. In the year 1981, what is the difference between the Population (in %) of Caribbean small states and Population (in %) of Ukraine?
Provide a short and direct response. -5.88. In the year 1981, what is the difference between the Population (in %) in Low & middle income and Population (in %) in Sudan?
Offer a terse response. 1.22. In the year 1981, what is the difference between the Population (in %) of Low & middle income and Population (in %) of Ukraine?
Give a very brief answer. -7.63. In the year 1981, what is the difference between the Population (in %) in Sudan and Population (in %) in Ukraine?
Offer a terse response. -8.85. In the year 1982, what is the difference between the Population (in %) of Caribbean small states and Population (in %) of Low & middle income?
Offer a very short reply. 1.76. In the year 1982, what is the difference between the Population (in %) in Caribbean small states and Population (in %) in Sudan?
Provide a short and direct response. 3.02. In the year 1982, what is the difference between the Population (in %) in Caribbean small states and Population (in %) in Ukraine?
Give a very brief answer. -5.68. In the year 1982, what is the difference between the Population (in %) in Low & middle income and Population (in %) in Sudan?
Your answer should be compact. 1.26. In the year 1982, what is the difference between the Population (in %) of Low & middle income and Population (in %) of Ukraine?
Make the answer very short. -7.45. In the year 1982, what is the difference between the Population (in %) in Sudan and Population (in %) in Ukraine?
Your response must be concise. -8.71. In the year 1983, what is the difference between the Population (in %) of Caribbean small states and Population (in %) of Low & middle income?
Ensure brevity in your answer.  1.77. In the year 1983, what is the difference between the Population (in %) in Caribbean small states and Population (in %) in Sudan?
Provide a succinct answer. 3.06. In the year 1983, what is the difference between the Population (in %) in Caribbean small states and Population (in %) in Ukraine?
Provide a succinct answer. -5.44. In the year 1983, what is the difference between the Population (in %) in Low & middle income and Population (in %) in Sudan?
Your answer should be compact. 1.29. In the year 1983, what is the difference between the Population (in %) in Low & middle income and Population (in %) in Ukraine?
Give a very brief answer. -7.21. In the year 1983, what is the difference between the Population (in %) of Sudan and Population (in %) of Ukraine?
Give a very brief answer. -8.5. In the year 1984, what is the difference between the Population (in %) in Caribbean small states and Population (in %) in Low & middle income?
Provide a short and direct response. 1.79. In the year 1984, what is the difference between the Population (in %) of Caribbean small states and Population (in %) of Sudan?
Offer a terse response. 3.1. In the year 1984, what is the difference between the Population (in %) in Caribbean small states and Population (in %) in Ukraine?
Offer a terse response. -5.24. In the year 1984, what is the difference between the Population (in %) of Low & middle income and Population (in %) of Sudan?
Ensure brevity in your answer.  1.31. In the year 1984, what is the difference between the Population (in %) of Low & middle income and Population (in %) of Ukraine?
Provide a succinct answer. -7.02. In the year 1984, what is the difference between the Population (in %) of Sudan and Population (in %) of Ukraine?
Ensure brevity in your answer.  -8.33. What is the ratio of the Population (in %) in Caribbean small states in 1977 to that in 1978?
Your answer should be compact. 0.98. What is the ratio of the Population (in %) in Low & middle income in 1977 to that in 1978?
Provide a succinct answer. 0.99. What is the ratio of the Population (in %) in Sudan in 1977 to that in 1978?
Make the answer very short. 1. What is the ratio of the Population (in %) of Ukraine in 1977 to that in 1978?
Keep it short and to the point. 0.97. What is the ratio of the Population (in %) in Caribbean small states in 1977 to that in 1979?
Your answer should be compact. 0.95. What is the ratio of the Population (in %) in Low & middle income in 1977 to that in 1979?
Provide a succinct answer. 0.98. What is the ratio of the Population (in %) of Sudan in 1977 to that in 1979?
Your response must be concise. 1.01. What is the ratio of the Population (in %) of Ukraine in 1977 to that in 1979?
Offer a terse response. 0.95. What is the ratio of the Population (in %) of Caribbean small states in 1977 to that in 1980?
Offer a very short reply. 0.94. What is the ratio of the Population (in %) in Low & middle income in 1977 to that in 1980?
Offer a terse response. 0.97. What is the ratio of the Population (in %) in Sudan in 1977 to that in 1980?
Ensure brevity in your answer.  1.01. What is the ratio of the Population (in %) in Ukraine in 1977 to that in 1980?
Keep it short and to the point. 0.95. What is the ratio of the Population (in %) of Caribbean small states in 1977 to that in 1981?
Offer a very short reply. 0.93. What is the ratio of the Population (in %) in Low & middle income in 1977 to that in 1981?
Your answer should be compact. 0.96. What is the ratio of the Population (in %) of Sudan in 1977 to that in 1981?
Make the answer very short. 1.01. What is the ratio of the Population (in %) in Ukraine in 1977 to that in 1981?
Your response must be concise. 0.95. What is the ratio of the Population (in %) in Caribbean small states in 1977 to that in 1982?
Keep it short and to the point. 0.92. What is the ratio of the Population (in %) in Low & middle income in 1977 to that in 1982?
Provide a succinct answer. 0.95. What is the ratio of the Population (in %) of Sudan in 1977 to that in 1982?
Keep it short and to the point. 1.01. What is the ratio of the Population (in %) of Ukraine in 1977 to that in 1982?
Your response must be concise. 0.96. What is the ratio of the Population (in %) in Caribbean small states in 1977 to that in 1983?
Ensure brevity in your answer.  0.91. What is the ratio of the Population (in %) in Low & middle income in 1977 to that in 1983?
Give a very brief answer. 0.95. What is the ratio of the Population (in %) of Sudan in 1977 to that in 1983?
Offer a very short reply. 1.01. What is the ratio of the Population (in %) in Ukraine in 1977 to that in 1983?
Provide a short and direct response. 0.98. What is the ratio of the Population (in %) of Caribbean small states in 1977 to that in 1984?
Make the answer very short. 0.91. What is the ratio of the Population (in %) of Low & middle income in 1977 to that in 1984?
Your answer should be compact. 0.94. What is the ratio of the Population (in %) in Sudan in 1977 to that in 1984?
Offer a terse response. 1.01. What is the ratio of the Population (in %) in Caribbean small states in 1978 to that in 1979?
Your answer should be compact. 0.98. What is the ratio of the Population (in %) of Low & middle income in 1978 to that in 1979?
Your answer should be very brief. 0.99. What is the ratio of the Population (in %) in Ukraine in 1978 to that in 1979?
Ensure brevity in your answer.  0.98. What is the ratio of the Population (in %) in Caribbean small states in 1978 to that in 1980?
Offer a terse response. 0.96. What is the ratio of the Population (in %) in Low & middle income in 1978 to that in 1980?
Make the answer very short. 0.98. What is the ratio of the Population (in %) in Sudan in 1978 to that in 1980?
Your answer should be very brief. 1.01. What is the ratio of the Population (in %) in Ukraine in 1978 to that in 1980?
Your answer should be very brief. 0.97. What is the ratio of the Population (in %) in Caribbean small states in 1978 to that in 1981?
Provide a short and direct response. 0.95. What is the ratio of the Population (in %) in Low & middle income in 1978 to that in 1981?
Your answer should be very brief. 0.97. What is the ratio of the Population (in %) in Ukraine in 1978 to that in 1981?
Provide a succinct answer. 0.98. What is the ratio of the Population (in %) of Caribbean small states in 1978 to that in 1982?
Your response must be concise. 0.94. What is the ratio of the Population (in %) of Low & middle income in 1978 to that in 1982?
Offer a very short reply. 0.96. What is the ratio of the Population (in %) in Ukraine in 1978 to that in 1982?
Your answer should be very brief. 0.99. What is the ratio of the Population (in %) in Caribbean small states in 1978 to that in 1983?
Make the answer very short. 0.93. What is the ratio of the Population (in %) of Low & middle income in 1978 to that in 1983?
Provide a succinct answer. 0.96. What is the ratio of the Population (in %) of Sudan in 1978 to that in 1983?
Provide a succinct answer. 1.01. What is the ratio of the Population (in %) of Ukraine in 1978 to that in 1983?
Give a very brief answer. 1.01. What is the ratio of the Population (in %) in Caribbean small states in 1978 to that in 1984?
Your response must be concise. 0.93. What is the ratio of the Population (in %) of Low & middle income in 1978 to that in 1984?
Give a very brief answer. 0.95. What is the ratio of the Population (in %) in Sudan in 1978 to that in 1984?
Your answer should be very brief. 1.01. What is the ratio of the Population (in %) of Ukraine in 1978 to that in 1984?
Provide a succinct answer. 1.02. What is the ratio of the Population (in %) of Caribbean small states in 1979 to that in 1980?
Your response must be concise. 0.98. What is the ratio of the Population (in %) in Sudan in 1979 to that in 1980?
Your answer should be very brief. 1. What is the ratio of the Population (in %) in Ukraine in 1979 to that in 1980?
Offer a terse response. 0.99. What is the ratio of the Population (in %) in Low & middle income in 1979 to that in 1981?
Offer a very short reply. 0.98. What is the ratio of the Population (in %) of Sudan in 1979 to that in 1981?
Provide a succinct answer. 1. What is the ratio of the Population (in %) in Caribbean small states in 1979 to that in 1982?
Keep it short and to the point. 0.96. What is the ratio of the Population (in %) of Low & middle income in 1979 to that in 1982?
Your response must be concise. 0.97. What is the ratio of the Population (in %) in Ukraine in 1979 to that in 1982?
Offer a very short reply. 1.01. What is the ratio of the Population (in %) of Caribbean small states in 1979 to that in 1983?
Your answer should be compact. 0.96. What is the ratio of the Population (in %) in Low & middle income in 1979 to that in 1983?
Offer a terse response. 0.97. What is the ratio of the Population (in %) of Sudan in 1979 to that in 1983?
Offer a terse response. 1.01. What is the ratio of the Population (in %) in Ukraine in 1979 to that in 1983?
Your answer should be very brief. 1.03. What is the ratio of the Population (in %) of Caribbean small states in 1979 to that in 1984?
Make the answer very short. 0.95. What is the ratio of the Population (in %) of Low & middle income in 1979 to that in 1984?
Your response must be concise. 0.96. What is the ratio of the Population (in %) in Sudan in 1979 to that in 1984?
Ensure brevity in your answer.  1.01. What is the ratio of the Population (in %) of Ukraine in 1979 to that in 1984?
Ensure brevity in your answer.  1.04. What is the ratio of the Population (in %) in Caribbean small states in 1980 to that in 1981?
Offer a very short reply. 0.99. What is the ratio of the Population (in %) of Low & middle income in 1980 to that in 1981?
Provide a succinct answer. 0.99. What is the ratio of the Population (in %) of Ukraine in 1980 to that in 1981?
Your answer should be very brief. 1. What is the ratio of the Population (in %) of Caribbean small states in 1980 to that in 1982?
Keep it short and to the point. 0.98. What is the ratio of the Population (in %) of Low & middle income in 1980 to that in 1982?
Ensure brevity in your answer.  0.98. What is the ratio of the Population (in %) in Caribbean small states in 1980 to that in 1983?
Offer a terse response. 0.97. What is the ratio of the Population (in %) in Low & middle income in 1980 to that in 1983?
Make the answer very short. 0.98. What is the ratio of the Population (in %) of Sudan in 1980 to that in 1983?
Provide a succinct answer. 1. What is the ratio of the Population (in %) of Ukraine in 1980 to that in 1983?
Offer a terse response. 1.03. What is the ratio of the Population (in %) of Caribbean small states in 1980 to that in 1984?
Make the answer very short. 0.97. What is the ratio of the Population (in %) of Low & middle income in 1980 to that in 1984?
Provide a succinct answer. 0.97. What is the ratio of the Population (in %) in Ukraine in 1980 to that in 1984?
Provide a succinct answer. 1.05. What is the ratio of the Population (in %) of Low & middle income in 1981 to that in 1982?
Ensure brevity in your answer.  0.99. What is the ratio of the Population (in %) of Sudan in 1981 to that in 1982?
Provide a succinct answer. 1. What is the ratio of the Population (in %) in Ukraine in 1981 to that in 1982?
Your response must be concise. 1.01. What is the ratio of the Population (in %) of Caribbean small states in 1981 to that in 1983?
Your answer should be very brief. 0.99. What is the ratio of the Population (in %) in Low & middle income in 1981 to that in 1983?
Give a very brief answer. 0.99. What is the ratio of the Population (in %) in Sudan in 1981 to that in 1983?
Give a very brief answer. 1. What is the ratio of the Population (in %) in Ukraine in 1981 to that in 1983?
Offer a very short reply. 1.03. What is the ratio of the Population (in %) in Caribbean small states in 1981 to that in 1984?
Ensure brevity in your answer.  0.98. What is the ratio of the Population (in %) in Low & middle income in 1981 to that in 1984?
Your answer should be compact. 0.98. What is the ratio of the Population (in %) in Ukraine in 1981 to that in 1984?
Ensure brevity in your answer.  1.05. What is the ratio of the Population (in %) of Caribbean small states in 1982 to that in 1983?
Ensure brevity in your answer.  0.99. What is the ratio of the Population (in %) in Low & middle income in 1982 to that in 1983?
Keep it short and to the point. 0.99. What is the ratio of the Population (in %) in Sudan in 1982 to that in 1983?
Provide a short and direct response. 1. What is the ratio of the Population (in %) of Ukraine in 1982 to that in 1983?
Provide a succinct answer. 1.02. What is the ratio of the Population (in %) in Caribbean small states in 1982 to that in 1984?
Your answer should be compact. 0.99. What is the ratio of the Population (in %) of Low & middle income in 1982 to that in 1984?
Make the answer very short. 0.99. What is the ratio of the Population (in %) of Ukraine in 1982 to that in 1984?
Offer a very short reply. 1.03. What is the ratio of the Population (in %) in Low & middle income in 1983 to that in 1984?
Ensure brevity in your answer.  1. What is the ratio of the Population (in %) of Sudan in 1983 to that in 1984?
Keep it short and to the point. 1. What is the ratio of the Population (in %) in Ukraine in 1983 to that in 1984?
Make the answer very short. 1.02. What is the difference between the highest and the second highest Population (in %) in Caribbean small states?
Provide a short and direct response. 0.03. What is the difference between the highest and the second highest Population (in %) of Sudan?
Provide a succinct answer. 0.01. What is the difference between the highest and the second highest Population (in %) in Ukraine?
Your answer should be very brief. 0.03. What is the difference between the highest and the lowest Population (in %) in Caribbean small states?
Give a very brief answer. 0.56. What is the difference between the highest and the lowest Population (in %) of Low & middle income?
Make the answer very short. 0.24. What is the difference between the highest and the lowest Population (in %) in Sudan?
Your answer should be compact. 0.04. What is the difference between the highest and the lowest Population (in %) of Ukraine?
Give a very brief answer. 0.64. 